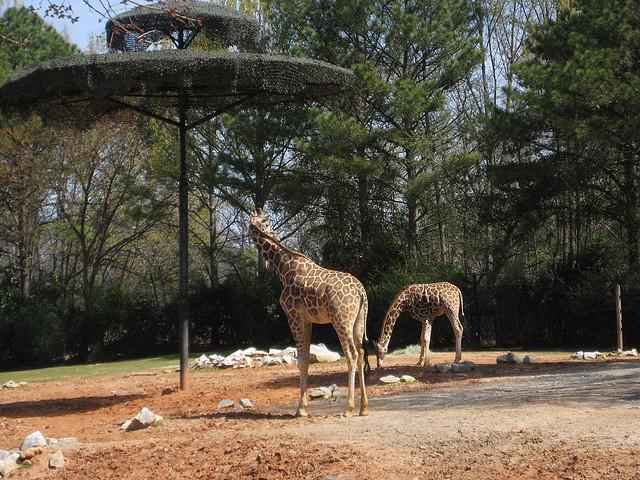How many giraffes are pictured?
Give a very brief answer. 2. How many giraffes can you see?
Give a very brief answer. 2. 